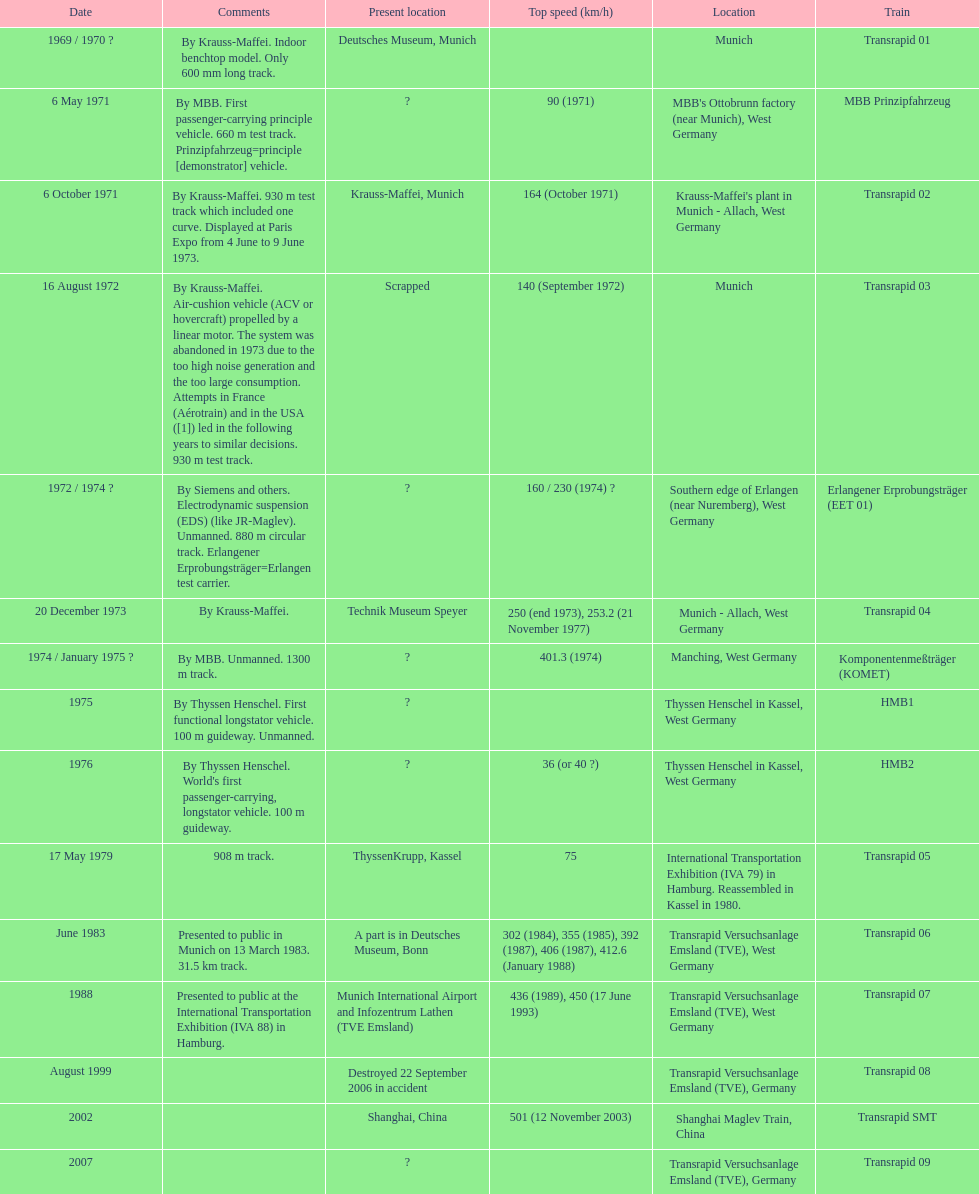How many trains other than the transrapid 07 can go faster than 450km/h? 1. 